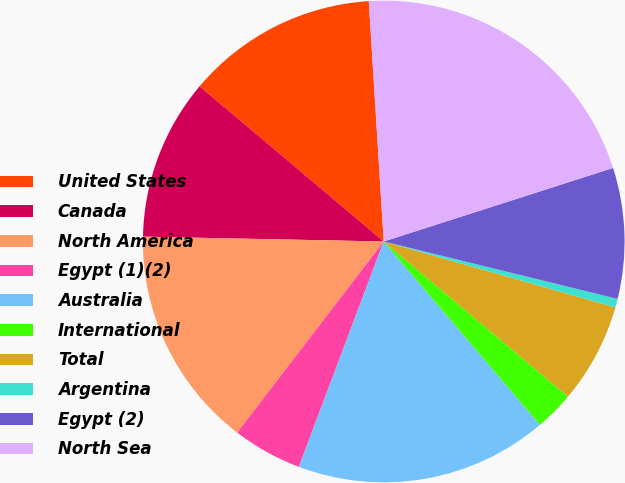Convert chart. <chart><loc_0><loc_0><loc_500><loc_500><pie_chart><fcel>United States<fcel>Canada<fcel>North America<fcel>Egypt (1)(2)<fcel>Australia<fcel>International<fcel>Total<fcel>Argentina<fcel>Egypt (2)<fcel>North Sea<nl><fcel>12.87%<fcel>10.82%<fcel>14.91%<fcel>4.68%<fcel>16.96%<fcel>2.63%<fcel>6.73%<fcel>0.58%<fcel>8.77%<fcel>21.05%<nl></chart> 